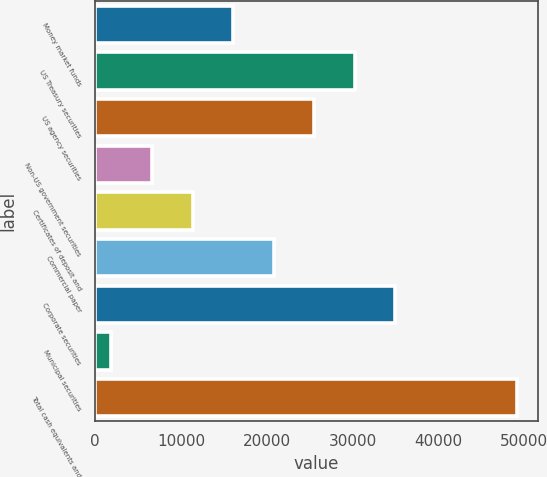Convert chart. <chart><loc_0><loc_0><loc_500><loc_500><bar_chart><fcel>Money market funds<fcel>US Treasury securities<fcel>US agency securities<fcel>Non-US government securities<fcel>Certificates of deposit and<fcel>Commercial paper<fcel>Corporate securities<fcel>Municipal securities<fcel>Total cash equivalents and<nl><fcel>16071.6<fcel>30244.2<fcel>25520<fcel>6623.2<fcel>11347.4<fcel>20795.8<fcel>34968.4<fcel>1899<fcel>49141<nl></chart> 